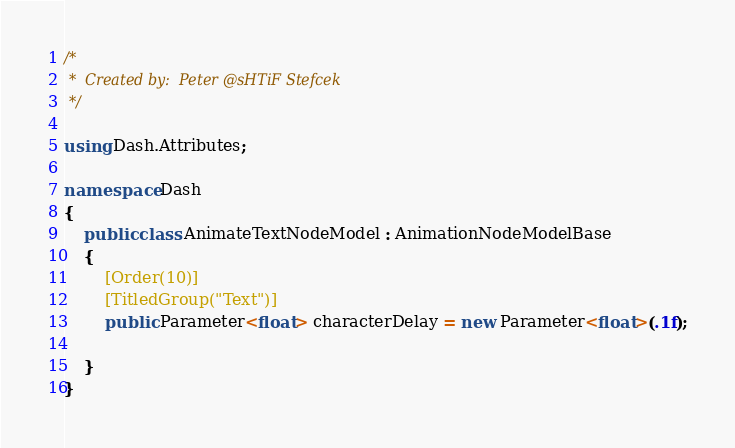<code> <loc_0><loc_0><loc_500><loc_500><_C#_>/*
 *	Created by:  Peter @sHTiF Stefcek
 */

using Dash.Attributes;

namespace Dash
{
    public class AnimateTextNodeModel : AnimationNodeModelBase
    {
        [Order(10)] 
        [TitledGroup("Text")] 
        public Parameter<float> characterDelay = new Parameter<float>(.1f);

    }
}</code> 